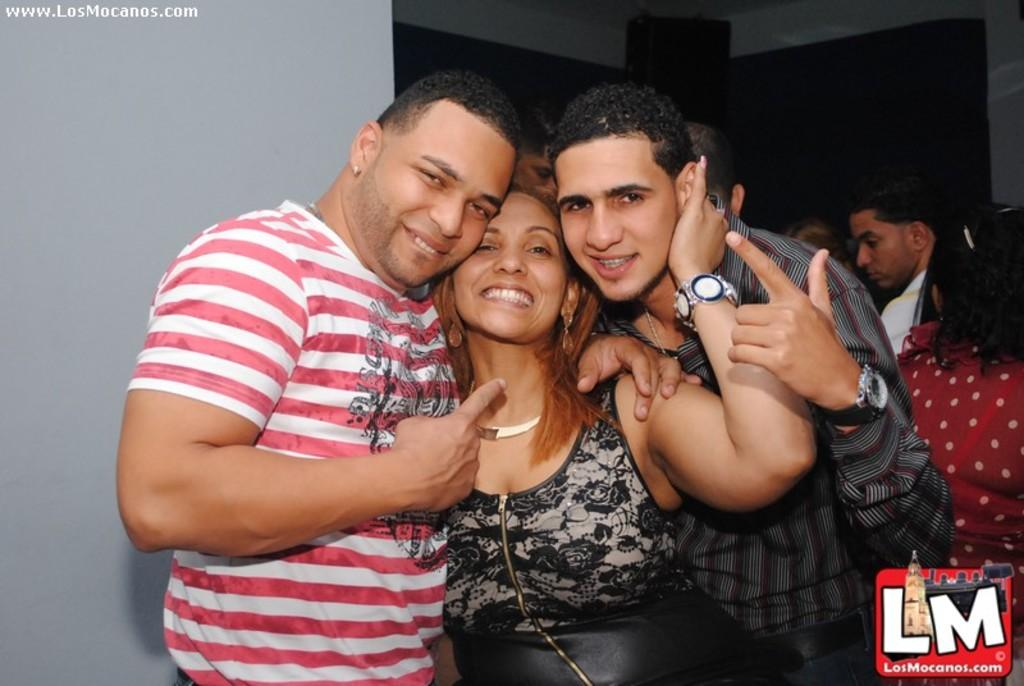How many people are in the image? There is a group of people in the image, but the exact number is not specified. What are the people in the image doing? The people are standing in the image. What can be seen in the background of the image? There is a wall in the background of the image. What type of key is being used for the activity in the image? There is no key or activity present in the image; it only shows a group of people standing with a wall in the background. 